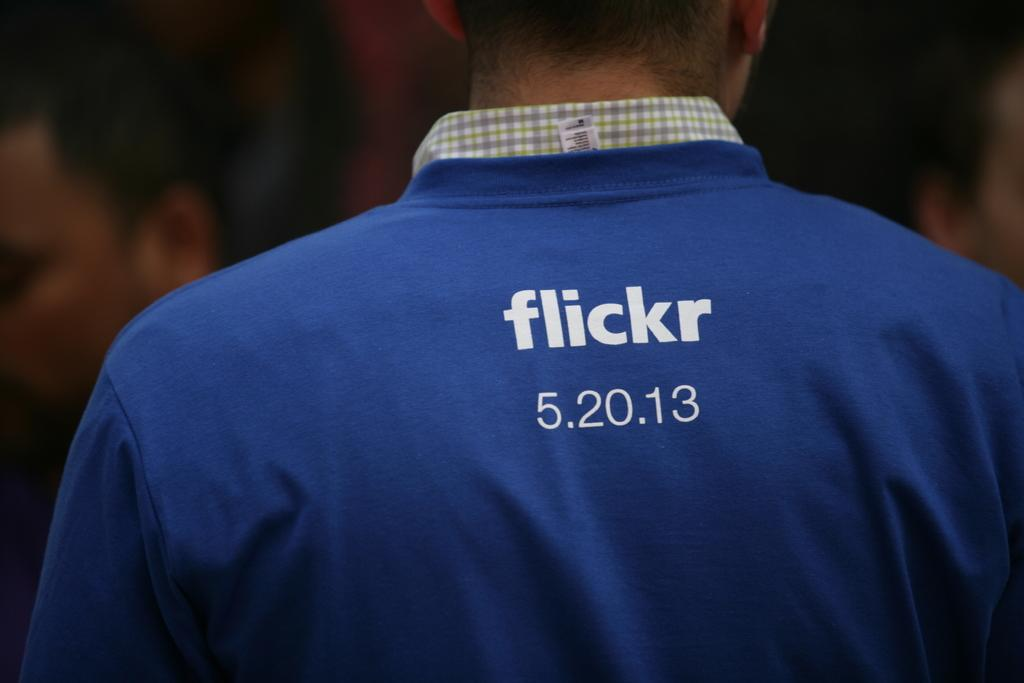Provide a one-sentence caption for the provided image. A standing up person wearing a blue Flickr shirt. 